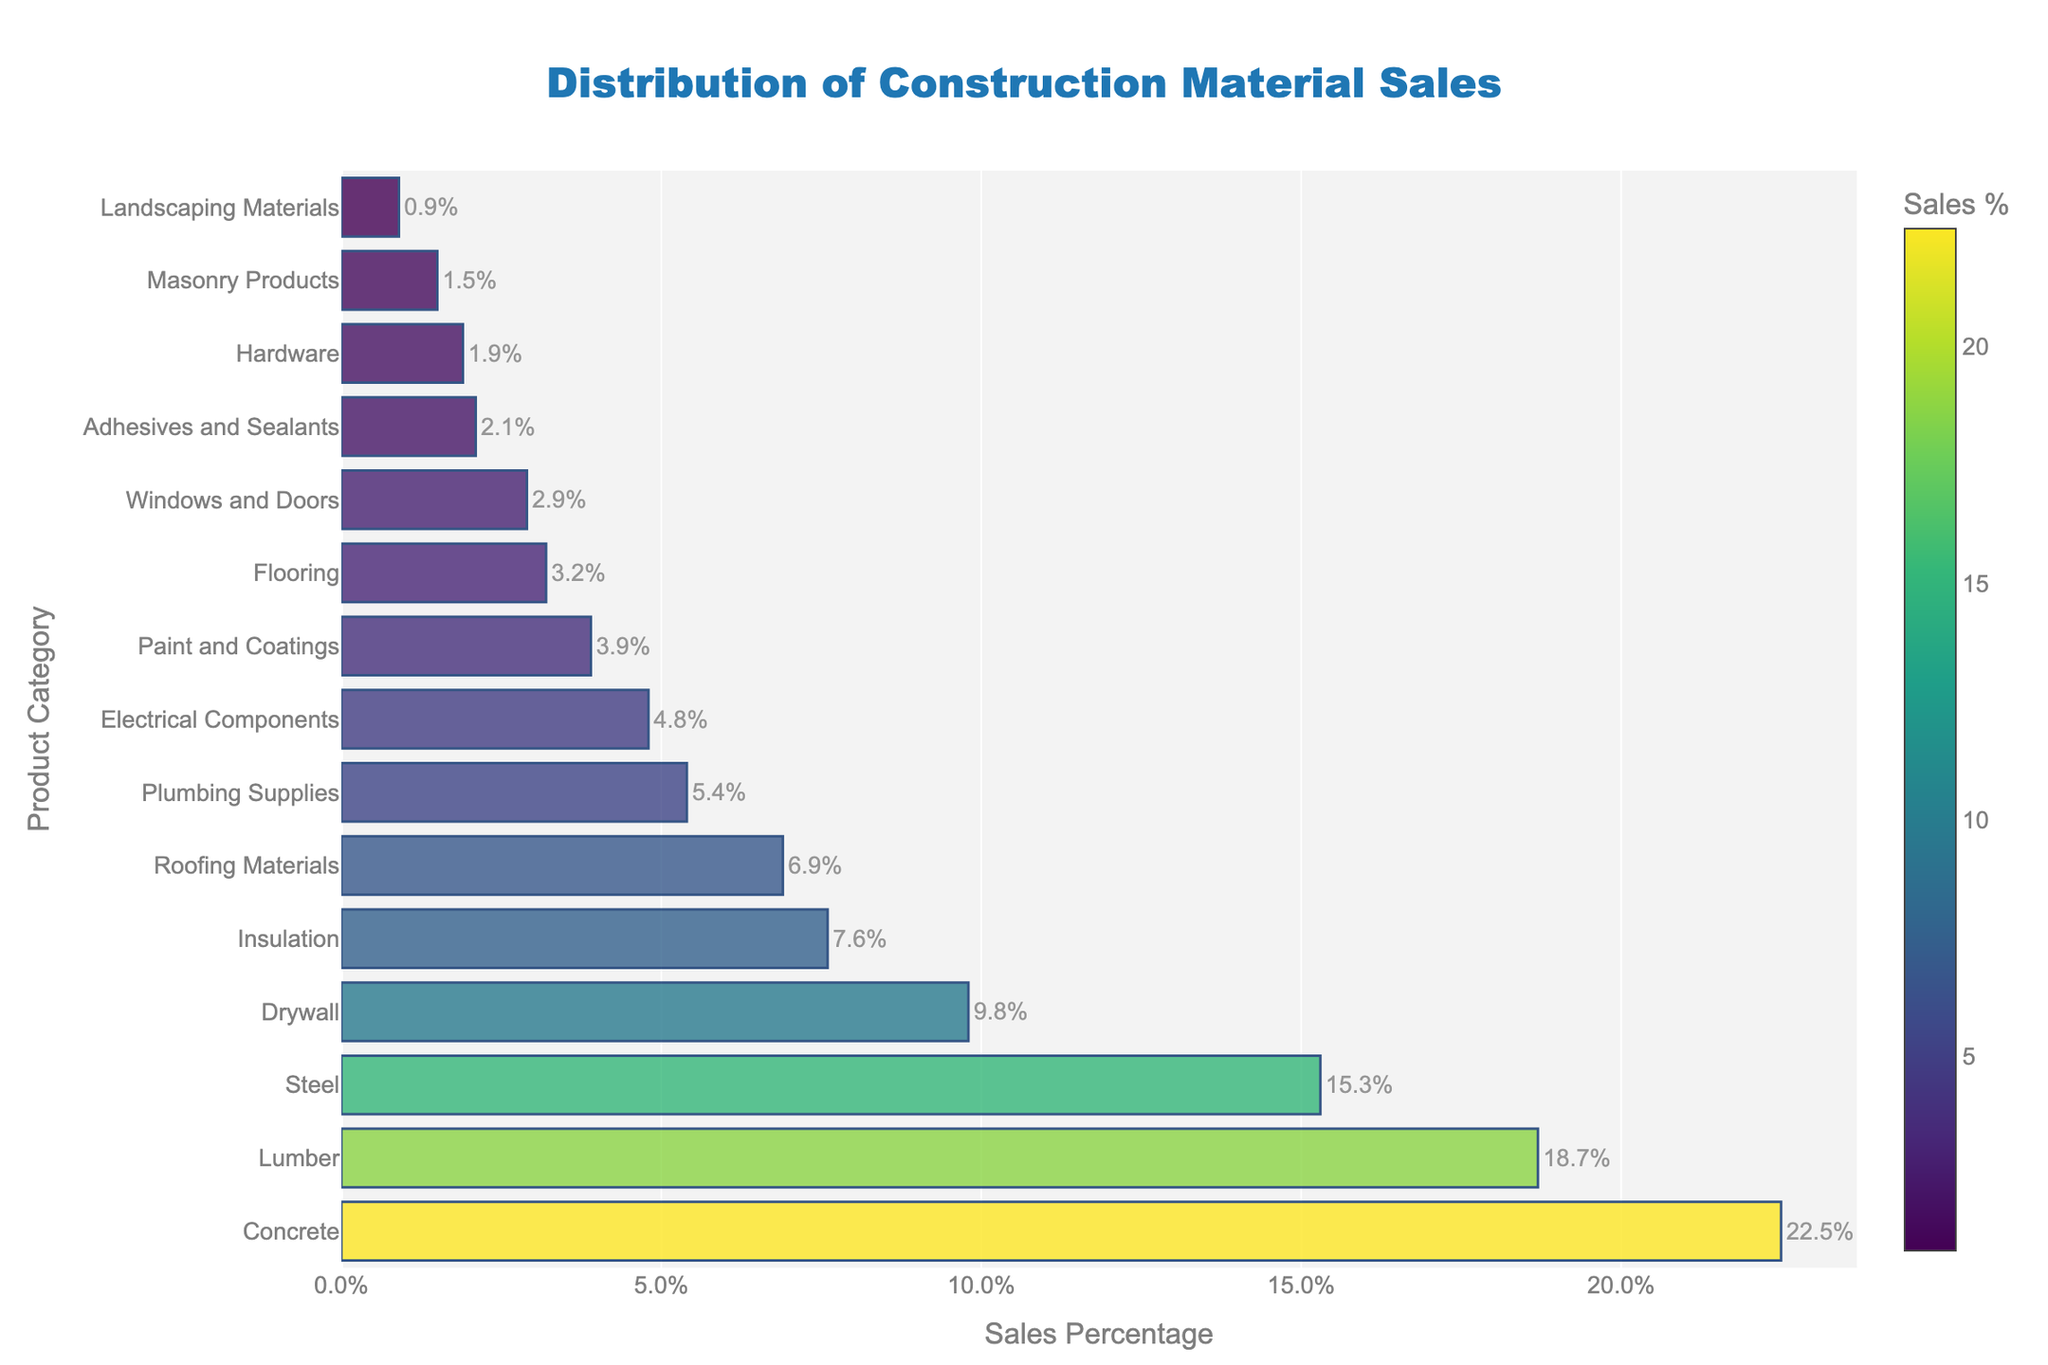What's the product category with the highest sales percentage? The product category with the highest sales percentage is determined by identifying the bar with the longest length. The bar for Concrete is the longest.
Answer: Concrete What's the difference in sales percentage between Lumber and Electrical Components? First, identify the sales percentages for Lumber and Electrical Components from the chart. Lumber has 18.7% and Electrical Components have 4.8%. Subtract the smaller percentage from the larger one: 18.7% - 4.8% = 13.9%.
Answer: 13.9% Which product has a higher sales percentage, Insulation or Plumbing Supplies? Compare the bars for Insulation and Plumbing Supplies. Insulation's bar is longer than Plumbing Supplies'. Therefore, Insulation has a higher sales percentage.
Answer: Insulation What's the combined sales percentage of Concrete, Lumber, and Steel? Identify the sales percentages: Concrete (22.5%), Lumber (18.7%), and Steel (15.3%). Sum these percentages: 22.5% + 18.7% + 15.3% = 56.5%.
Answer: 56.5% What are the top three product categories in terms of sales percentage? Determine the three longest bars in the chart. They belong to Concrete, Lumber, and Steel.
Answer: Concrete, Lumber, Steel How much lower is the sales percentage of Flooring compared to Roofing Materials? Identify the sales percentages: Roofing Materials (6.9%) and Flooring (3.2%). Subtract the smaller percentage from the larger one: 6.9% - 3.2% = 3.7%.
Answer: 3.7% Which product category has the shortest bar on the chart? The shortest bar visually represents the lowest sales percentage. Landscaping Materials is the shortest.
Answer: Landscaping Materials Is the sales percentage of Drywall greater than the sales percentage of Paint and Coatings? Compare the bars for Drywall and Paint and Coatings. The bar for Drywall is longer than the one for Paint and Coatings, indicating a greater sales percentage.
Answer: Yes What's the average sales percentage of the bottom five product categories? Identify the sales percentages of the bottom five categories: Hardware (1.9%), Masonry Products (1.5%), Landscaping Materials (0.9%), Adhesives and Sealants (2.1%), and Windows and Doors (2.9%). Sum these percentages and divide by 5: (1.9% + 1.5% + 0.9% + 2.1% + 2.9%) / 5 = 1.86%.
Answer: 1.86% 